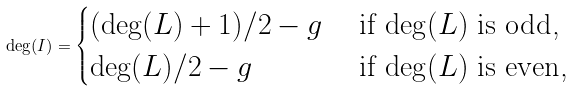<formula> <loc_0><loc_0><loc_500><loc_500>\deg ( I ) = \begin{cases} ( \deg ( L ) + 1 ) / 2 - g & \text { if $\deg( L)$ is odd,} \\ \deg ( L ) / 2 - g & \text { if $\deg( L)$ is even,} \end{cases}</formula> 